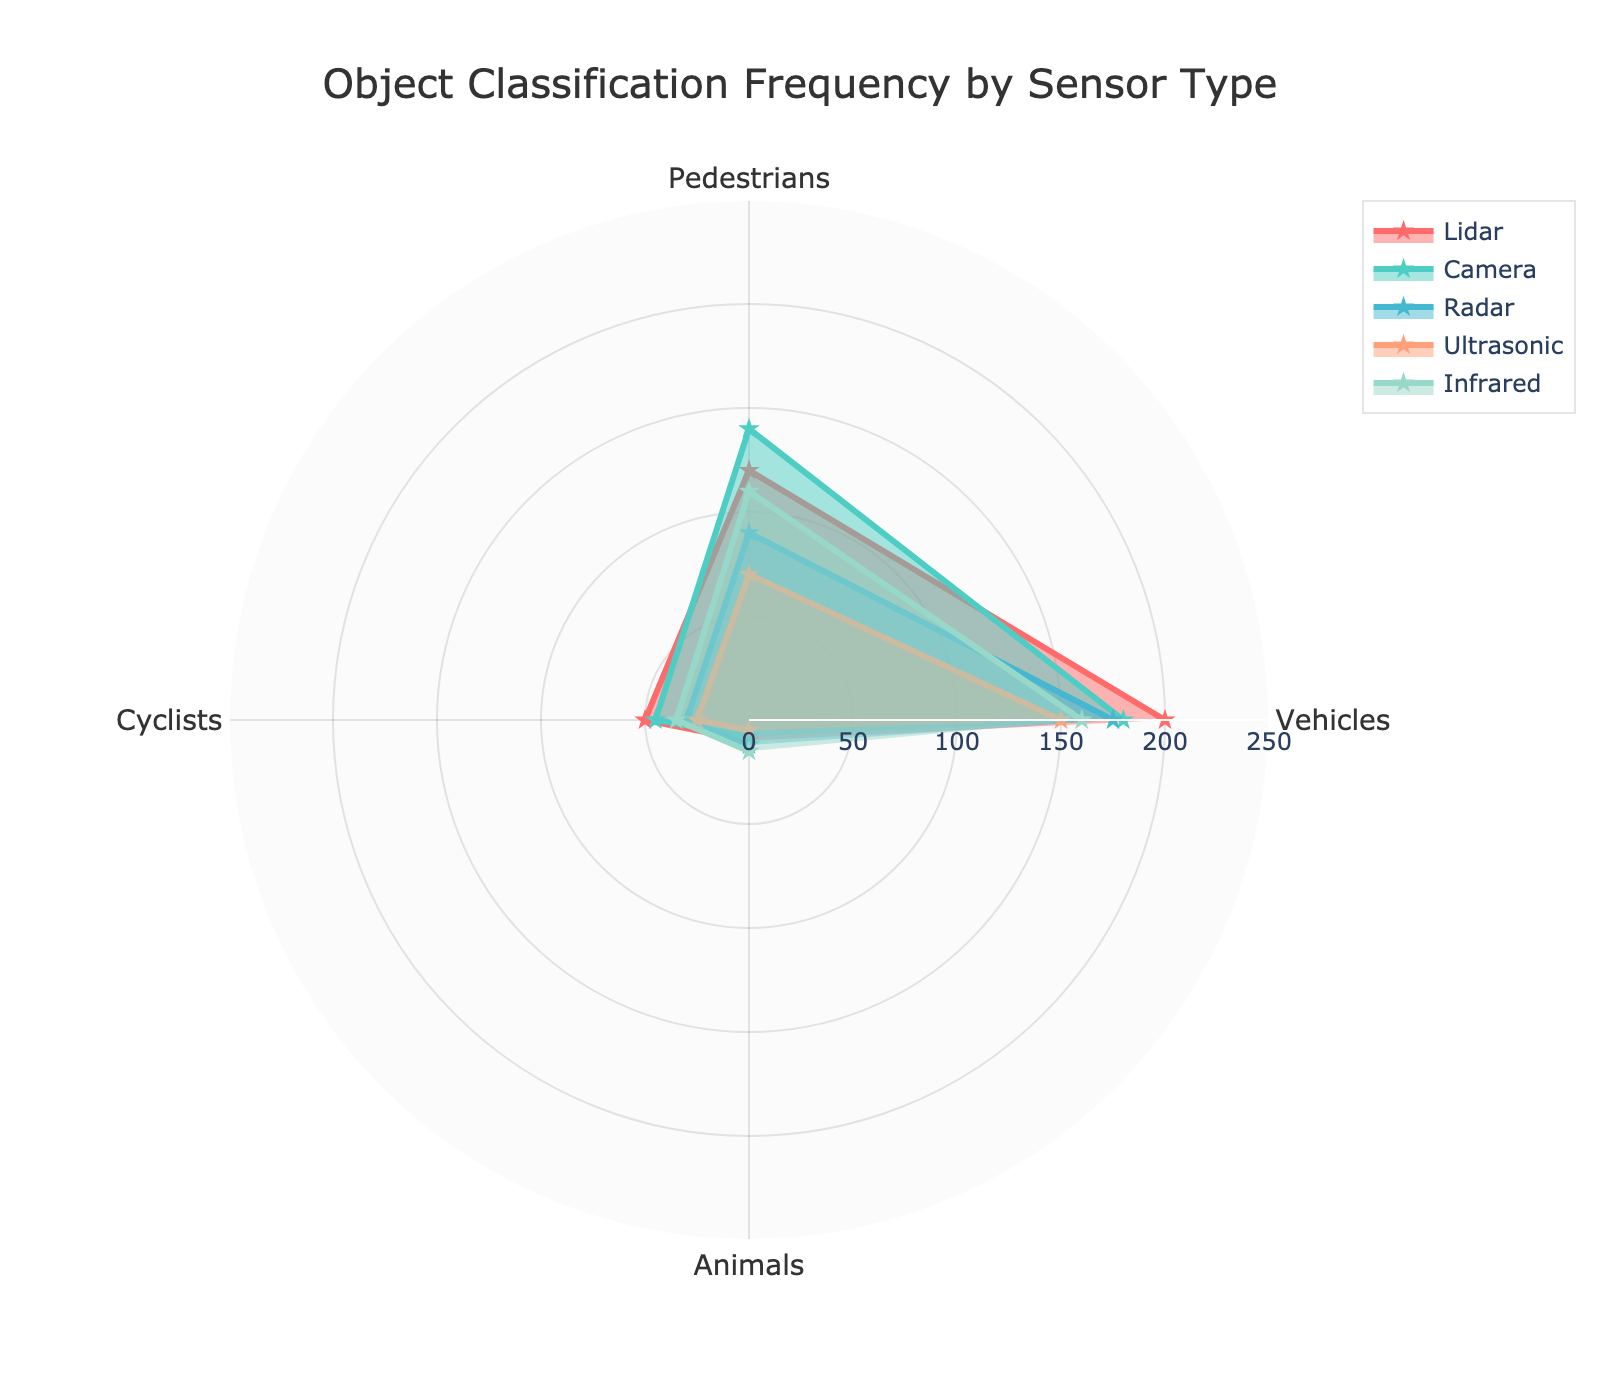What's the title of the figure? The title is found at the top center of the radar chart.
Answer: Object Classification Frequency by Sensor Type Which sensor detects the most vehicles? By examining the radar chart, the outer-most data point in the 'Vehicles' category indicates the sensor type.
Answer: Lidar How many pedestrians were detected by the Radar sensor? Look at the 'Pedestrians' axis and find the data point corresponding to the Radar sensor.
Answer: 90 Which sensor type detects the least amount of animals? Examine the 'Animals' axis and identify the most inner data point across all sensors.
Answer: Ultrasonic Which sensor type has the smallest range in object detections (from the minimum to the maximum value)? Calculate the range for each sensor type and determine the smallest range.
Answer: Ultrasonic Which two sensors have the closest detection frequency of cyclists? Compare the 'Cyclists' axis data points to see which two are closest in value.
Answer: Camera and Infrared On average, how many objects does the Camera sensor detect per category? Sum the detections in each category for Camera and divide by the number of categories.
Answer: 93.25 Between Lidar and Camera, which sensor detects more pedestrians and by how much? Subtract the number of pedestrians detected by Camera from those detected by Lidar.
Answer: Camera by 20 Compare the detection of animals between Infrared and Radar sensors. Which one detects more and by how much? Subtract the number of animals detected by Radar from those detected by Infrared.
Answer: Infrared by 3 Which sensor type shows the highest detection frequency across any category, and what is that frequency? By checking each axis, find the maximum value and the corresponding sensor type.
Answer: Lidar with 200 (Vehicles) 